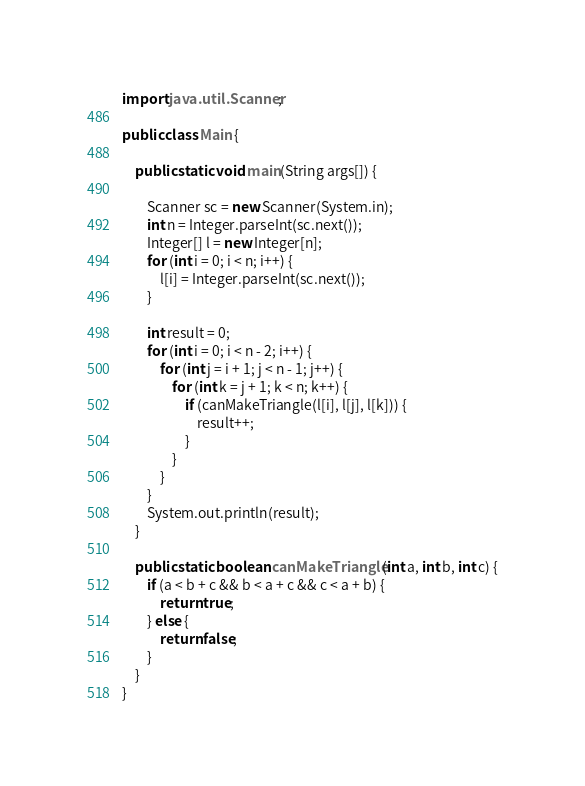Convert code to text. <code><loc_0><loc_0><loc_500><loc_500><_Java_>import java.util.Scanner;

public class Main {

    public static void main(String args[]) {

        Scanner sc = new Scanner(System.in);
        int n = Integer.parseInt(sc.next());
        Integer[] l = new Integer[n];
        for (int i = 0; i < n; i++) {
            l[i] = Integer.parseInt(sc.next());
        }

        int result = 0;
        for (int i = 0; i < n - 2; i++) {
            for (int j = i + 1; j < n - 1; j++) {
                for (int k = j + 1; k < n; k++) {
                    if (canMakeTriangle(l[i], l[j], l[k])) {
                        result++;
                    }
                }
            }
        }
        System.out.println(result);
    }

    public static boolean canMakeTriangle(int a, int b, int c) {
        if (a < b + c && b < a + c && c < a + b) {
            return true;
        } else {
            return false;
        }
    }
}</code> 